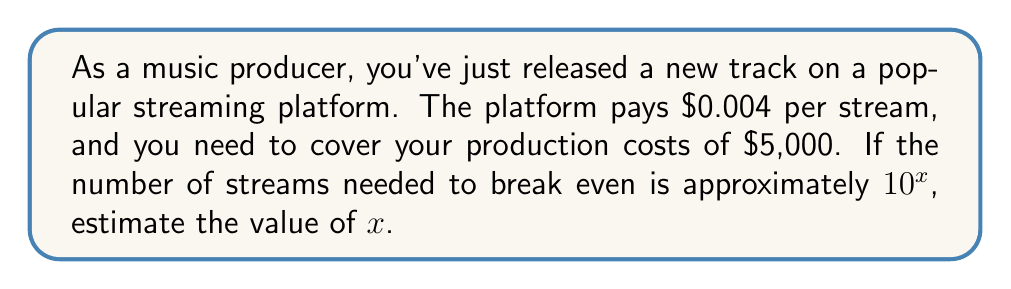What is the answer to this math problem? Let's approach this step-by-step:

1) First, we need to calculate how many streams are needed to break even:
   
   $$\text{Number of streams} = \frac{\text{Production costs}}{\text{Payment per stream}}$$

2) Plugging in the values:
   
   $$\text{Number of streams} = \frac{\$5,000}{\$0.004}$$

3) Simplifying:
   
   $$\text{Number of streams} = 1,250,000$$

4) Now, we need to express this as a power of 10. In other words, we're looking for $x$ such that:
   
   $$10^x \approx 1,250,000$$

5) Taking the logarithm (base 10) of both sides:
   
   $$\log_{10}(10^x) \approx \log_{10}(1,250,000)$$

6) The left side simplifies to $x$:
   
   $$x \approx \log_{10}(1,250,000)$$

7) Using a calculator or estimating:
   
   $$x \approx 6.097$$

8) Rounding to the nearest integer:
   
   $$x \approx 6$$

Therefore, the number of streams needed is approximately $10^6$.
Answer: $x \approx 6$ 